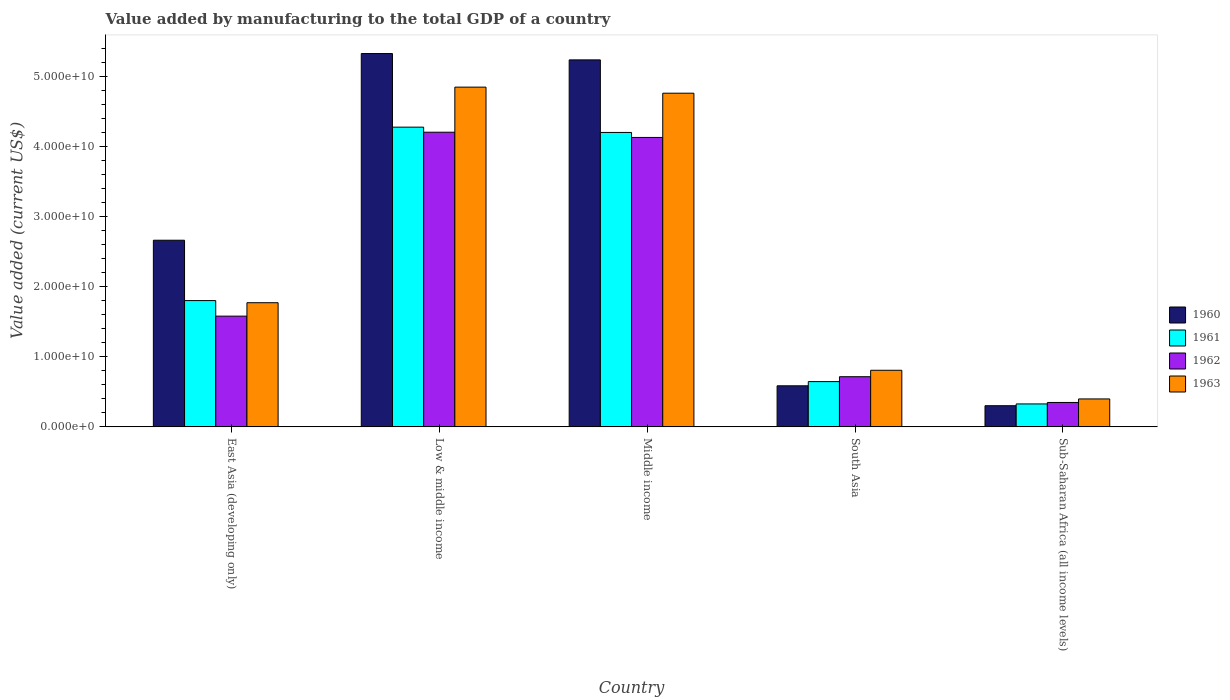How many different coloured bars are there?
Ensure brevity in your answer.  4. How many groups of bars are there?
Your response must be concise. 5. Are the number of bars per tick equal to the number of legend labels?
Make the answer very short. Yes. What is the label of the 1st group of bars from the left?
Your answer should be compact. East Asia (developing only). In how many cases, is the number of bars for a given country not equal to the number of legend labels?
Provide a succinct answer. 0. What is the value added by manufacturing to the total GDP in 1961 in South Asia?
Make the answer very short. 6.45e+09. Across all countries, what is the maximum value added by manufacturing to the total GDP in 1963?
Provide a short and direct response. 4.84e+1. Across all countries, what is the minimum value added by manufacturing to the total GDP in 1960?
Provide a short and direct response. 3.02e+09. In which country was the value added by manufacturing to the total GDP in 1962 maximum?
Offer a very short reply. Low & middle income. In which country was the value added by manufacturing to the total GDP in 1963 minimum?
Provide a short and direct response. Sub-Saharan Africa (all income levels). What is the total value added by manufacturing to the total GDP in 1961 in the graph?
Keep it short and to the point. 1.12e+11. What is the difference between the value added by manufacturing to the total GDP in 1960 in East Asia (developing only) and that in Low & middle income?
Offer a very short reply. -2.66e+1. What is the difference between the value added by manufacturing to the total GDP in 1961 in Sub-Saharan Africa (all income levels) and the value added by manufacturing to the total GDP in 1960 in East Asia (developing only)?
Your answer should be very brief. -2.33e+1. What is the average value added by manufacturing to the total GDP in 1963 per country?
Offer a terse response. 2.51e+1. What is the difference between the value added by manufacturing to the total GDP of/in 1961 and value added by manufacturing to the total GDP of/in 1962 in East Asia (developing only)?
Provide a succinct answer. 2.22e+09. What is the ratio of the value added by manufacturing to the total GDP in 1961 in Low & middle income to that in South Asia?
Your answer should be compact. 6.62. What is the difference between the highest and the second highest value added by manufacturing to the total GDP in 1963?
Provide a short and direct response. -2.99e+1. What is the difference between the highest and the lowest value added by manufacturing to the total GDP in 1961?
Provide a succinct answer. 3.95e+1. In how many countries, is the value added by manufacturing to the total GDP in 1962 greater than the average value added by manufacturing to the total GDP in 1962 taken over all countries?
Your response must be concise. 2. Is the sum of the value added by manufacturing to the total GDP in 1963 in Middle income and Sub-Saharan Africa (all income levels) greater than the maximum value added by manufacturing to the total GDP in 1961 across all countries?
Give a very brief answer. Yes. Is it the case that in every country, the sum of the value added by manufacturing to the total GDP in 1963 and value added by manufacturing to the total GDP in 1962 is greater than the sum of value added by manufacturing to the total GDP in 1960 and value added by manufacturing to the total GDP in 1961?
Offer a terse response. No. What does the 4th bar from the left in Sub-Saharan Africa (all income levels) represents?
Offer a terse response. 1963. Is it the case that in every country, the sum of the value added by manufacturing to the total GDP in 1960 and value added by manufacturing to the total GDP in 1963 is greater than the value added by manufacturing to the total GDP in 1961?
Give a very brief answer. Yes. How many bars are there?
Ensure brevity in your answer.  20. Are all the bars in the graph horizontal?
Give a very brief answer. No. Are the values on the major ticks of Y-axis written in scientific E-notation?
Make the answer very short. Yes. Does the graph contain any zero values?
Your answer should be compact. No. How are the legend labels stacked?
Provide a short and direct response. Vertical. What is the title of the graph?
Your response must be concise. Value added by manufacturing to the total GDP of a country. What is the label or title of the X-axis?
Ensure brevity in your answer.  Country. What is the label or title of the Y-axis?
Ensure brevity in your answer.  Value added (current US$). What is the Value added (current US$) of 1960 in East Asia (developing only)?
Ensure brevity in your answer.  2.66e+1. What is the Value added (current US$) in 1961 in East Asia (developing only)?
Your answer should be compact. 1.80e+1. What is the Value added (current US$) of 1962 in East Asia (developing only)?
Your response must be concise. 1.58e+1. What is the Value added (current US$) of 1963 in East Asia (developing only)?
Offer a very short reply. 1.77e+1. What is the Value added (current US$) in 1960 in Low & middle income?
Provide a short and direct response. 5.32e+1. What is the Value added (current US$) in 1961 in Low & middle income?
Offer a very short reply. 4.27e+1. What is the Value added (current US$) in 1962 in Low & middle income?
Your response must be concise. 4.20e+1. What is the Value added (current US$) in 1963 in Low & middle income?
Offer a terse response. 4.84e+1. What is the Value added (current US$) in 1960 in Middle income?
Keep it short and to the point. 5.23e+1. What is the Value added (current US$) of 1961 in Middle income?
Ensure brevity in your answer.  4.20e+1. What is the Value added (current US$) in 1962 in Middle income?
Provide a succinct answer. 4.13e+1. What is the Value added (current US$) of 1963 in Middle income?
Offer a terse response. 4.76e+1. What is the Value added (current US$) in 1960 in South Asia?
Give a very brief answer. 5.86e+09. What is the Value added (current US$) in 1961 in South Asia?
Your answer should be very brief. 6.45e+09. What is the Value added (current US$) of 1962 in South Asia?
Offer a very short reply. 7.15e+09. What is the Value added (current US$) of 1963 in South Asia?
Provide a short and direct response. 8.07e+09. What is the Value added (current US$) in 1960 in Sub-Saharan Africa (all income levels)?
Give a very brief answer. 3.02e+09. What is the Value added (current US$) in 1961 in Sub-Saharan Africa (all income levels)?
Offer a very short reply. 3.27e+09. What is the Value added (current US$) of 1962 in Sub-Saharan Africa (all income levels)?
Provide a succinct answer. 3.48e+09. What is the Value added (current US$) in 1963 in Sub-Saharan Africa (all income levels)?
Make the answer very short. 3.98e+09. Across all countries, what is the maximum Value added (current US$) in 1960?
Give a very brief answer. 5.32e+1. Across all countries, what is the maximum Value added (current US$) of 1961?
Keep it short and to the point. 4.27e+1. Across all countries, what is the maximum Value added (current US$) of 1962?
Give a very brief answer. 4.20e+1. Across all countries, what is the maximum Value added (current US$) of 1963?
Provide a short and direct response. 4.84e+1. Across all countries, what is the minimum Value added (current US$) of 1960?
Offer a very short reply. 3.02e+09. Across all countries, what is the minimum Value added (current US$) in 1961?
Offer a very short reply. 3.27e+09. Across all countries, what is the minimum Value added (current US$) of 1962?
Offer a terse response. 3.48e+09. Across all countries, what is the minimum Value added (current US$) in 1963?
Your response must be concise. 3.98e+09. What is the total Value added (current US$) in 1960 in the graph?
Make the answer very short. 1.41e+11. What is the total Value added (current US$) in 1961 in the graph?
Your answer should be compact. 1.12e+11. What is the total Value added (current US$) in 1962 in the graph?
Your response must be concise. 1.10e+11. What is the total Value added (current US$) of 1963 in the graph?
Provide a succinct answer. 1.26e+11. What is the difference between the Value added (current US$) in 1960 in East Asia (developing only) and that in Low & middle income?
Your answer should be compact. -2.66e+1. What is the difference between the Value added (current US$) in 1961 in East Asia (developing only) and that in Low & middle income?
Make the answer very short. -2.47e+1. What is the difference between the Value added (current US$) of 1962 in East Asia (developing only) and that in Low & middle income?
Provide a short and direct response. -2.62e+1. What is the difference between the Value added (current US$) in 1963 in East Asia (developing only) and that in Low & middle income?
Offer a very short reply. -3.07e+1. What is the difference between the Value added (current US$) of 1960 in East Asia (developing only) and that in Middle income?
Offer a terse response. -2.57e+1. What is the difference between the Value added (current US$) in 1961 in East Asia (developing only) and that in Middle income?
Provide a succinct answer. -2.40e+1. What is the difference between the Value added (current US$) in 1962 in East Asia (developing only) and that in Middle income?
Your answer should be very brief. -2.55e+1. What is the difference between the Value added (current US$) in 1963 in East Asia (developing only) and that in Middle income?
Ensure brevity in your answer.  -2.99e+1. What is the difference between the Value added (current US$) in 1960 in East Asia (developing only) and that in South Asia?
Your answer should be compact. 2.08e+1. What is the difference between the Value added (current US$) in 1961 in East Asia (developing only) and that in South Asia?
Offer a very short reply. 1.16e+1. What is the difference between the Value added (current US$) in 1962 in East Asia (developing only) and that in South Asia?
Your response must be concise. 8.63e+09. What is the difference between the Value added (current US$) in 1963 in East Asia (developing only) and that in South Asia?
Keep it short and to the point. 9.63e+09. What is the difference between the Value added (current US$) in 1960 in East Asia (developing only) and that in Sub-Saharan Africa (all income levels)?
Keep it short and to the point. 2.36e+1. What is the difference between the Value added (current US$) in 1961 in East Asia (developing only) and that in Sub-Saharan Africa (all income levels)?
Provide a short and direct response. 1.47e+1. What is the difference between the Value added (current US$) of 1962 in East Asia (developing only) and that in Sub-Saharan Africa (all income levels)?
Offer a terse response. 1.23e+1. What is the difference between the Value added (current US$) of 1963 in East Asia (developing only) and that in Sub-Saharan Africa (all income levels)?
Offer a terse response. 1.37e+1. What is the difference between the Value added (current US$) in 1960 in Low & middle income and that in Middle income?
Your response must be concise. 9.04e+08. What is the difference between the Value added (current US$) in 1961 in Low & middle income and that in Middle income?
Ensure brevity in your answer.  7.56e+08. What is the difference between the Value added (current US$) in 1962 in Low & middle income and that in Middle income?
Provide a short and direct response. 7.46e+08. What is the difference between the Value added (current US$) in 1963 in Low & middle income and that in Middle income?
Keep it short and to the point. 8.65e+08. What is the difference between the Value added (current US$) in 1960 in Low & middle income and that in South Asia?
Offer a very short reply. 4.74e+1. What is the difference between the Value added (current US$) in 1961 in Low & middle income and that in South Asia?
Offer a terse response. 3.63e+1. What is the difference between the Value added (current US$) of 1962 in Low & middle income and that in South Asia?
Offer a very short reply. 3.49e+1. What is the difference between the Value added (current US$) of 1963 in Low & middle income and that in South Asia?
Provide a succinct answer. 4.04e+1. What is the difference between the Value added (current US$) of 1960 in Low & middle income and that in Sub-Saharan Africa (all income levels)?
Make the answer very short. 5.02e+1. What is the difference between the Value added (current US$) in 1961 in Low & middle income and that in Sub-Saharan Africa (all income levels)?
Ensure brevity in your answer.  3.95e+1. What is the difference between the Value added (current US$) in 1962 in Low & middle income and that in Sub-Saharan Africa (all income levels)?
Provide a succinct answer. 3.85e+1. What is the difference between the Value added (current US$) of 1963 in Low & middle income and that in Sub-Saharan Africa (all income levels)?
Provide a succinct answer. 4.44e+1. What is the difference between the Value added (current US$) of 1960 in Middle income and that in South Asia?
Your answer should be compact. 4.65e+1. What is the difference between the Value added (current US$) in 1961 in Middle income and that in South Asia?
Your response must be concise. 3.55e+1. What is the difference between the Value added (current US$) in 1962 in Middle income and that in South Asia?
Your answer should be very brief. 3.41e+1. What is the difference between the Value added (current US$) of 1963 in Middle income and that in South Asia?
Your answer should be compact. 3.95e+1. What is the difference between the Value added (current US$) in 1960 in Middle income and that in Sub-Saharan Africa (all income levels)?
Make the answer very short. 4.93e+1. What is the difference between the Value added (current US$) of 1961 in Middle income and that in Sub-Saharan Africa (all income levels)?
Ensure brevity in your answer.  3.87e+1. What is the difference between the Value added (current US$) in 1962 in Middle income and that in Sub-Saharan Africa (all income levels)?
Give a very brief answer. 3.78e+1. What is the difference between the Value added (current US$) of 1963 in Middle income and that in Sub-Saharan Africa (all income levels)?
Offer a very short reply. 4.36e+1. What is the difference between the Value added (current US$) in 1960 in South Asia and that in Sub-Saharan Africa (all income levels)?
Your response must be concise. 2.84e+09. What is the difference between the Value added (current US$) in 1961 in South Asia and that in Sub-Saharan Africa (all income levels)?
Your response must be concise. 3.18e+09. What is the difference between the Value added (current US$) of 1962 in South Asia and that in Sub-Saharan Africa (all income levels)?
Offer a terse response. 3.67e+09. What is the difference between the Value added (current US$) of 1963 in South Asia and that in Sub-Saharan Africa (all income levels)?
Offer a terse response. 4.08e+09. What is the difference between the Value added (current US$) in 1960 in East Asia (developing only) and the Value added (current US$) in 1961 in Low & middle income?
Your response must be concise. -1.61e+1. What is the difference between the Value added (current US$) in 1960 in East Asia (developing only) and the Value added (current US$) in 1962 in Low & middle income?
Ensure brevity in your answer.  -1.54e+1. What is the difference between the Value added (current US$) in 1960 in East Asia (developing only) and the Value added (current US$) in 1963 in Low & middle income?
Your answer should be very brief. -2.18e+1. What is the difference between the Value added (current US$) in 1961 in East Asia (developing only) and the Value added (current US$) in 1962 in Low & middle income?
Ensure brevity in your answer.  -2.40e+1. What is the difference between the Value added (current US$) of 1961 in East Asia (developing only) and the Value added (current US$) of 1963 in Low & middle income?
Keep it short and to the point. -3.04e+1. What is the difference between the Value added (current US$) of 1962 in East Asia (developing only) and the Value added (current US$) of 1963 in Low & middle income?
Your answer should be very brief. -3.26e+1. What is the difference between the Value added (current US$) of 1960 in East Asia (developing only) and the Value added (current US$) of 1961 in Middle income?
Ensure brevity in your answer.  -1.54e+1. What is the difference between the Value added (current US$) of 1960 in East Asia (developing only) and the Value added (current US$) of 1962 in Middle income?
Give a very brief answer. -1.47e+1. What is the difference between the Value added (current US$) of 1960 in East Asia (developing only) and the Value added (current US$) of 1963 in Middle income?
Offer a very short reply. -2.10e+1. What is the difference between the Value added (current US$) of 1961 in East Asia (developing only) and the Value added (current US$) of 1962 in Middle income?
Give a very brief answer. -2.33e+1. What is the difference between the Value added (current US$) of 1961 in East Asia (developing only) and the Value added (current US$) of 1963 in Middle income?
Provide a succinct answer. -2.96e+1. What is the difference between the Value added (current US$) of 1962 in East Asia (developing only) and the Value added (current US$) of 1963 in Middle income?
Offer a terse response. -3.18e+1. What is the difference between the Value added (current US$) in 1960 in East Asia (developing only) and the Value added (current US$) in 1961 in South Asia?
Keep it short and to the point. 2.02e+1. What is the difference between the Value added (current US$) of 1960 in East Asia (developing only) and the Value added (current US$) of 1962 in South Asia?
Your answer should be compact. 1.95e+1. What is the difference between the Value added (current US$) of 1960 in East Asia (developing only) and the Value added (current US$) of 1963 in South Asia?
Give a very brief answer. 1.85e+1. What is the difference between the Value added (current US$) of 1961 in East Asia (developing only) and the Value added (current US$) of 1962 in South Asia?
Offer a terse response. 1.09e+1. What is the difference between the Value added (current US$) in 1961 in East Asia (developing only) and the Value added (current US$) in 1963 in South Asia?
Your answer should be compact. 9.94e+09. What is the difference between the Value added (current US$) in 1962 in East Asia (developing only) and the Value added (current US$) in 1963 in South Asia?
Make the answer very short. 7.72e+09. What is the difference between the Value added (current US$) in 1960 in East Asia (developing only) and the Value added (current US$) in 1961 in Sub-Saharan Africa (all income levels)?
Offer a terse response. 2.33e+1. What is the difference between the Value added (current US$) of 1960 in East Asia (developing only) and the Value added (current US$) of 1962 in Sub-Saharan Africa (all income levels)?
Your answer should be compact. 2.31e+1. What is the difference between the Value added (current US$) in 1960 in East Asia (developing only) and the Value added (current US$) in 1963 in Sub-Saharan Africa (all income levels)?
Your response must be concise. 2.26e+1. What is the difference between the Value added (current US$) of 1961 in East Asia (developing only) and the Value added (current US$) of 1962 in Sub-Saharan Africa (all income levels)?
Offer a very short reply. 1.45e+1. What is the difference between the Value added (current US$) of 1961 in East Asia (developing only) and the Value added (current US$) of 1963 in Sub-Saharan Africa (all income levels)?
Give a very brief answer. 1.40e+1. What is the difference between the Value added (current US$) in 1962 in East Asia (developing only) and the Value added (current US$) in 1963 in Sub-Saharan Africa (all income levels)?
Your answer should be very brief. 1.18e+1. What is the difference between the Value added (current US$) of 1960 in Low & middle income and the Value added (current US$) of 1961 in Middle income?
Keep it short and to the point. 1.12e+1. What is the difference between the Value added (current US$) of 1960 in Low & middle income and the Value added (current US$) of 1962 in Middle income?
Your answer should be very brief. 1.20e+1. What is the difference between the Value added (current US$) of 1960 in Low & middle income and the Value added (current US$) of 1963 in Middle income?
Keep it short and to the point. 5.65e+09. What is the difference between the Value added (current US$) of 1961 in Low & middle income and the Value added (current US$) of 1962 in Middle income?
Provide a short and direct response. 1.47e+09. What is the difference between the Value added (current US$) of 1961 in Low & middle income and the Value added (current US$) of 1963 in Middle income?
Your answer should be compact. -4.84e+09. What is the difference between the Value added (current US$) of 1962 in Low & middle income and the Value added (current US$) of 1963 in Middle income?
Ensure brevity in your answer.  -5.56e+09. What is the difference between the Value added (current US$) of 1960 in Low & middle income and the Value added (current US$) of 1961 in South Asia?
Offer a very short reply. 4.68e+1. What is the difference between the Value added (current US$) of 1960 in Low & middle income and the Value added (current US$) of 1962 in South Asia?
Give a very brief answer. 4.61e+1. What is the difference between the Value added (current US$) of 1960 in Low & middle income and the Value added (current US$) of 1963 in South Asia?
Your answer should be compact. 4.52e+1. What is the difference between the Value added (current US$) of 1961 in Low & middle income and the Value added (current US$) of 1962 in South Asia?
Give a very brief answer. 3.56e+1. What is the difference between the Value added (current US$) in 1961 in Low & middle income and the Value added (current US$) in 1963 in South Asia?
Make the answer very short. 3.47e+1. What is the difference between the Value added (current US$) in 1962 in Low & middle income and the Value added (current US$) in 1963 in South Asia?
Your answer should be very brief. 3.39e+1. What is the difference between the Value added (current US$) in 1960 in Low & middle income and the Value added (current US$) in 1961 in Sub-Saharan Africa (all income levels)?
Your answer should be compact. 4.99e+1. What is the difference between the Value added (current US$) of 1960 in Low & middle income and the Value added (current US$) of 1962 in Sub-Saharan Africa (all income levels)?
Offer a terse response. 4.97e+1. What is the difference between the Value added (current US$) of 1960 in Low & middle income and the Value added (current US$) of 1963 in Sub-Saharan Africa (all income levels)?
Provide a succinct answer. 4.92e+1. What is the difference between the Value added (current US$) in 1961 in Low & middle income and the Value added (current US$) in 1962 in Sub-Saharan Africa (all income levels)?
Make the answer very short. 3.92e+1. What is the difference between the Value added (current US$) in 1961 in Low & middle income and the Value added (current US$) in 1963 in Sub-Saharan Africa (all income levels)?
Give a very brief answer. 3.87e+1. What is the difference between the Value added (current US$) in 1962 in Low & middle income and the Value added (current US$) in 1963 in Sub-Saharan Africa (all income levels)?
Provide a short and direct response. 3.80e+1. What is the difference between the Value added (current US$) in 1960 in Middle income and the Value added (current US$) in 1961 in South Asia?
Offer a terse response. 4.59e+1. What is the difference between the Value added (current US$) of 1960 in Middle income and the Value added (current US$) of 1962 in South Asia?
Your answer should be compact. 4.52e+1. What is the difference between the Value added (current US$) in 1960 in Middle income and the Value added (current US$) in 1963 in South Asia?
Provide a short and direct response. 4.42e+1. What is the difference between the Value added (current US$) of 1961 in Middle income and the Value added (current US$) of 1962 in South Asia?
Your response must be concise. 3.48e+1. What is the difference between the Value added (current US$) of 1961 in Middle income and the Value added (current US$) of 1963 in South Asia?
Give a very brief answer. 3.39e+1. What is the difference between the Value added (current US$) of 1962 in Middle income and the Value added (current US$) of 1963 in South Asia?
Your answer should be compact. 3.32e+1. What is the difference between the Value added (current US$) of 1960 in Middle income and the Value added (current US$) of 1961 in Sub-Saharan Africa (all income levels)?
Your answer should be compact. 4.90e+1. What is the difference between the Value added (current US$) of 1960 in Middle income and the Value added (current US$) of 1962 in Sub-Saharan Africa (all income levels)?
Your response must be concise. 4.88e+1. What is the difference between the Value added (current US$) of 1960 in Middle income and the Value added (current US$) of 1963 in Sub-Saharan Africa (all income levels)?
Offer a very short reply. 4.83e+1. What is the difference between the Value added (current US$) in 1961 in Middle income and the Value added (current US$) in 1962 in Sub-Saharan Africa (all income levels)?
Your response must be concise. 3.85e+1. What is the difference between the Value added (current US$) of 1961 in Middle income and the Value added (current US$) of 1963 in Sub-Saharan Africa (all income levels)?
Make the answer very short. 3.80e+1. What is the difference between the Value added (current US$) in 1962 in Middle income and the Value added (current US$) in 1963 in Sub-Saharan Africa (all income levels)?
Offer a terse response. 3.73e+1. What is the difference between the Value added (current US$) of 1960 in South Asia and the Value added (current US$) of 1961 in Sub-Saharan Africa (all income levels)?
Your answer should be compact. 2.58e+09. What is the difference between the Value added (current US$) in 1960 in South Asia and the Value added (current US$) in 1962 in Sub-Saharan Africa (all income levels)?
Offer a very short reply. 2.37e+09. What is the difference between the Value added (current US$) in 1960 in South Asia and the Value added (current US$) in 1963 in Sub-Saharan Africa (all income levels)?
Keep it short and to the point. 1.87e+09. What is the difference between the Value added (current US$) of 1961 in South Asia and the Value added (current US$) of 1962 in Sub-Saharan Africa (all income levels)?
Your answer should be very brief. 2.97e+09. What is the difference between the Value added (current US$) of 1961 in South Asia and the Value added (current US$) of 1963 in Sub-Saharan Africa (all income levels)?
Provide a short and direct response. 2.47e+09. What is the difference between the Value added (current US$) in 1962 in South Asia and the Value added (current US$) in 1963 in Sub-Saharan Africa (all income levels)?
Make the answer very short. 3.17e+09. What is the average Value added (current US$) in 1960 per country?
Your response must be concise. 2.82e+1. What is the average Value added (current US$) of 1961 per country?
Keep it short and to the point. 2.25e+1. What is the average Value added (current US$) in 1962 per country?
Give a very brief answer. 2.19e+1. What is the average Value added (current US$) of 1963 per country?
Keep it short and to the point. 2.51e+1. What is the difference between the Value added (current US$) in 1960 and Value added (current US$) in 1961 in East Asia (developing only)?
Your answer should be very brief. 8.60e+09. What is the difference between the Value added (current US$) in 1960 and Value added (current US$) in 1962 in East Asia (developing only)?
Offer a terse response. 1.08e+1. What is the difference between the Value added (current US$) in 1960 and Value added (current US$) in 1963 in East Asia (developing only)?
Provide a succinct answer. 8.91e+09. What is the difference between the Value added (current US$) in 1961 and Value added (current US$) in 1962 in East Asia (developing only)?
Make the answer very short. 2.22e+09. What is the difference between the Value added (current US$) in 1961 and Value added (current US$) in 1963 in East Asia (developing only)?
Your answer should be very brief. 3.04e+08. What is the difference between the Value added (current US$) in 1962 and Value added (current US$) in 1963 in East Asia (developing only)?
Provide a succinct answer. -1.91e+09. What is the difference between the Value added (current US$) in 1960 and Value added (current US$) in 1961 in Low & middle income?
Your answer should be compact. 1.05e+1. What is the difference between the Value added (current US$) in 1960 and Value added (current US$) in 1962 in Low & middle income?
Your response must be concise. 1.12e+1. What is the difference between the Value added (current US$) of 1960 and Value added (current US$) of 1963 in Low & middle income?
Make the answer very short. 4.79e+09. What is the difference between the Value added (current US$) of 1961 and Value added (current US$) of 1962 in Low & middle income?
Offer a terse response. 7.22e+08. What is the difference between the Value added (current US$) in 1961 and Value added (current US$) in 1963 in Low & middle income?
Keep it short and to the point. -5.70e+09. What is the difference between the Value added (current US$) of 1962 and Value added (current US$) of 1963 in Low & middle income?
Ensure brevity in your answer.  -6.43e+09. What is the difference between the Value added (current US$) of 1960 and Value added (current US$) of 1961 in Middle income?
Ensure brevity in your answer.  1.03e+1. What is the difference between the Value added (current US$) in 1960 and Value added (current US$) in 1962 in Middle income?
Your answer should be very brief. 1.11e+1. What is the difference between the Value added (current US$) in 1960 and Value added (current US$) in 1963 in Middle income?
Provide a short and direct response. 4.75e+09. What is the difference between the Value added (current US$) in 1961 and Value added (current US$) in 1962 in Middle income?
Your answer should be very brief. 7.12e+08. What is the difference between the Value added (current US$) of 1961 and Value added (current US$) of 1963 in Middle income?
Your answer should be compact. -5.59e+09. What is the difference between the Value added (current US$) of 1962 and Value added (current US$) of 1963 in Middle income?
Your response must be concise. -6.31e+09. What is the difference between the Value added (current US$) in 1960 and Value added (current US$) in 1961 in South Asia?
Offer a terse response. -5.98e+08. What is the difference between the Value added (current US$) in 1960 and Value added (current US$) in 1962 in South Asia?
Offer a very short reply. -1.30e+09. What is the difference between the Value added (current US$) of 1960 and Value added (current US$) of 1963 in South Asia?
Offer a terse response. -2.21e+09. What is the difference between the Value added (current US$) in 1961 and Value added (current US$) in 1962 in South Asia?
Your response must be concise. -6.98e+08. What is the difference between the Value added (current US$) of 1961 and Value added (current US$) of 1963 in South Asia?
Your response must be concise. -1.61e+09. What is the difference between the Value added (current US$) in 1962 and Value added (current US$) in 1963 in South Asia?
Offer a terse response. -9.17e+08. What is the difference between the Value added (current US$) of 1960 and Value added (current US$) of 1961 in Sub-Saharan Africa (all income levels)?
Offer a terse response. -2.55e+08. What is the difference between the Value added (current US$) in 1960 and Value added (current US$) in 1962 in Sub-Saharan Africa (all income levels)?
Your answer should be compact. -4.65e+08. What is the difference between the Value added (current US$) of 1960 and Value added (current US$) of 1963 in Sub-Saharan Africa (all income levels)?
Make the answer very short. -9.68e+08. What is the difference between the Value added (current US$) in 1961 and Value added (current US$) in 1962 in Sub-Saharan Africa (all income levels)?
Make the answer very short. -2.09e+08. What is the difference between the Value added (current US$) of 1961 and Value added (current US$) of 1963 in Sub-Saharan Africa (all income levels)?
Make the answer very short. -7.12e+08. What is the difference between the Value added (current US$) of 1962 and Value added (current US$) of 1963 in Sub-Saharan Africa (all income levels)?
Make the answer very short. -5.03e+08. What is the ratio of the Value added (current US$) in 1960 in East Asia (developing only) to that in Low & middle income?
Ensure brevity in your answer.  0.5. What is the ratio of the Value added (current US$) of 1961 in East Asia (developing only) to that in Low & middle income?
Keep it short and to the point. 0.42. What is the ratio of the Value added (current US$) in 1962 in East Asia (developing only) to that in Low & middle income?
Make the answer very short. 0.38. What is the ratio of the Value added (current US$) in 1963 in East Asia (developing only) to that in Low & middle income?
Offer a terse response. 0.37. What is the ratio of the Value added (current US$) in 1960 in East Asia (developing only) to that in Middle income?
Your answer should be compact. 0.51. What is the ratio of the Value added (current US$) in 1961 in East Asia (developing only) to that in Middle income?
Keep it short and to the point. 0.43. What is the ratio of the Value added (current US$) in 1962 in East Asia (developing only) to that in Middle income?
Your answer should be compact. 0.38. What is the ratio of the Value added (current US$) of 1963 in East Asia (developing only) to that in Middle income?
Your answer should be compact. 0.37. What is the ratio of the Value added (current US$) in 1960 in East Asia (developing only) to that in South Asia?
Keep it short and to the point. 4.54. What is the ratio of the Value added (current US$) in 1961 in East Asia (developing only) to that in South Asia?
Offer a very short reply. 2.79. What is the ratio of the Value added (current US$) in 1962 in East Asia (developing only) to that in South Asia?
Give a very brief answer. 2.21. What is the ratio of the Value added (current US$) in 1963 in East Asia (developing only) to that in South Asia?
Offer a very short reply. 2.19. What is the ratio of the Value added (current US$) of 1960 in East Asia (developing only) to that in Sub-Saharan Africa (all income levels)?
Your answer should be compact. 8.82. What is the ratio of the Value added (current US$) of 1961 in East Asia (developing only) to that in Sub-Saharan Africa (all income levels)?
Offer a terse response. 5.5. What is the ratio of the Value added (current US$) in 1962 in East Asia (developing only) to that in Sub-Saharan Africa (all income levels)?
Keep it short and to the point. 4.54. What is the ratio of the Value added (current US$) of 1963 in East Asia (developing only) to that in Sub-Saharan Africa (all income levels)?
Ensure brevity in your answer.  4.44. What is the ratio of the Value added (current US$) in 1960 in Low & middle income to that in Middle income?
Provide a succinct answer. 1.02. What is the ratio of the Value added (current US$) of 1961 in Low & middle income to that in Middle income?
Ensure brevity in your answer.  1.02. What is the ratio of the Value added (current US$) in 1962 in Low & middle income to that in Middle income?
Provide a short and direct response. 1.02. What is the ratio of the Value added (current US$) in 1963 in Low & middle income to that in Middle income?
Ensure brevity in your answer.  1.02. What is the ratio of the Value added (current US$) of 1960 in Low & middle income to that in South Asia?
Make the answer very short. 9.09. What is the ratio of the Value added (current US$) of 1961 in Low & middle income to that in South Asia?
Ensure brevity in your answer.  6.62. What is the ratio of the Value added (current US$) of 1962 in Low & middle income to that in South Asia?
Give a very brief answer. 5.87. What is the ratio of the Value added (current US$) in 1963 in Low & middle income to that in South Asia?
Your answer should be compact. 6. What is the ratio of the Value added (current US$) of 1960 in Low & middle income to that in Sub-Saharan Africa (all income levels)?
Your response must be concise. 17.65. What is the ratio of the Value added (current US$) in 1961 in Low & middle income to that in Sub-Saharan Africa (all income levels)?
Your answer should be compact. 13.06. What is the ratio of the Value added (current US$) of 1962 in Low & middle income to that in Sub-Saharan Africa (all income levels)?
Make the answer very short. 12.07. What is the ratio of the Value added (current US$) of 1963 in Low & middle income to that in Sub-Saharan Africa (all income levels)?
Your answer should be very brief. 12.16. What is the ratio of the Value added (current US$) of 1960 in Middle income to that in South Asia?
Provide a succinct answer. 8.93. What is the ratio of the Value added (current US$) in 1961 in Middle income to that in South Asia?
Make the answer very short. 6.5. What is the ratio of the Value added (current US$) in 1962 in Middle income to that in South Asia?
Your answer should be compact. 5.77. What is the ratio of the Value added (current US$) of 1963 in Middle income to that in South Asia?
Give a very brief answer. 5.9. What is the ratio of the Value added (current US$) in 1960 in Middle income to that in Sub-Saharan Africa (all income levels)?
Provide a succinct answer. 17.35. What is the ratio of the Value added (current US$) of 1961 in Middle income to that in Sub-Saharan Africa (all income levels)?
Provide a succinct answer. 12.83. What is the ratio of the Value added (current US$) in 1962 in Middle income to that in Sub-Saharan Africa (all income levels)?
Offer a terse response. 11.85. What is the ratio of the Value added (current US$) of 1963 in Middle income to that in Sub-Saharan Africa (all income levels)?
Make the answer very short. 11.94. What is the ratio of the Value added (current US$) of 1960 in South Asia to that in Sub-Saharan Africa (all income levels)?
Offer a very short reply. 1.94. What is the ratio of the Value added (current US$) of 1961 in South Asia to that in Sub-Saharan Africa (all income levels)?
Your response must be concise. 1.97. What is the ratio of the Value added (current US$) in 1962 in South Asia to that in Sub-Saharan Africa (all income levels)?
Ensure brevity in your answer.  2.05. What is the ratio of the Value added (current US$) of 1963 in South Asia to that in Sub-Saharan Africa (all income levels)?
Your response must be concise. 2.03. What is the difference between the highest and the second highest Value added (current US$) in 1960?
Provide a short and direct response. 9.04e+08. What is the difference between the highest and the second highest Value added (current US$) in 1961?
Give a very brief answer. 7.56e+08. What is the difference between the highest and the second highest Value added (current US$) in 1962?
Your answer should be compact. 7.46e+08. What is the difference between the highest and the second highest Value added (current US$) in 1963?
Your answer should be compact. 8.65e+08. What is the difference between the highest and the lowest Value added (current US$) in 1960?
Your answer should be very brief. 5.02e+1. What is the difference between the highest and the lowest Value added (current US$) in 1961?
Make the answer very short. 3.95e+1. What is the difference between the highest and the lowest Value added (current US$) of 1962?
Offer a very short reply. 3.85e+1. What is the difference between the highest and the lowest Value added (current US$) of 1963?
Ensure brevity in your answer.  4.44e+1. 